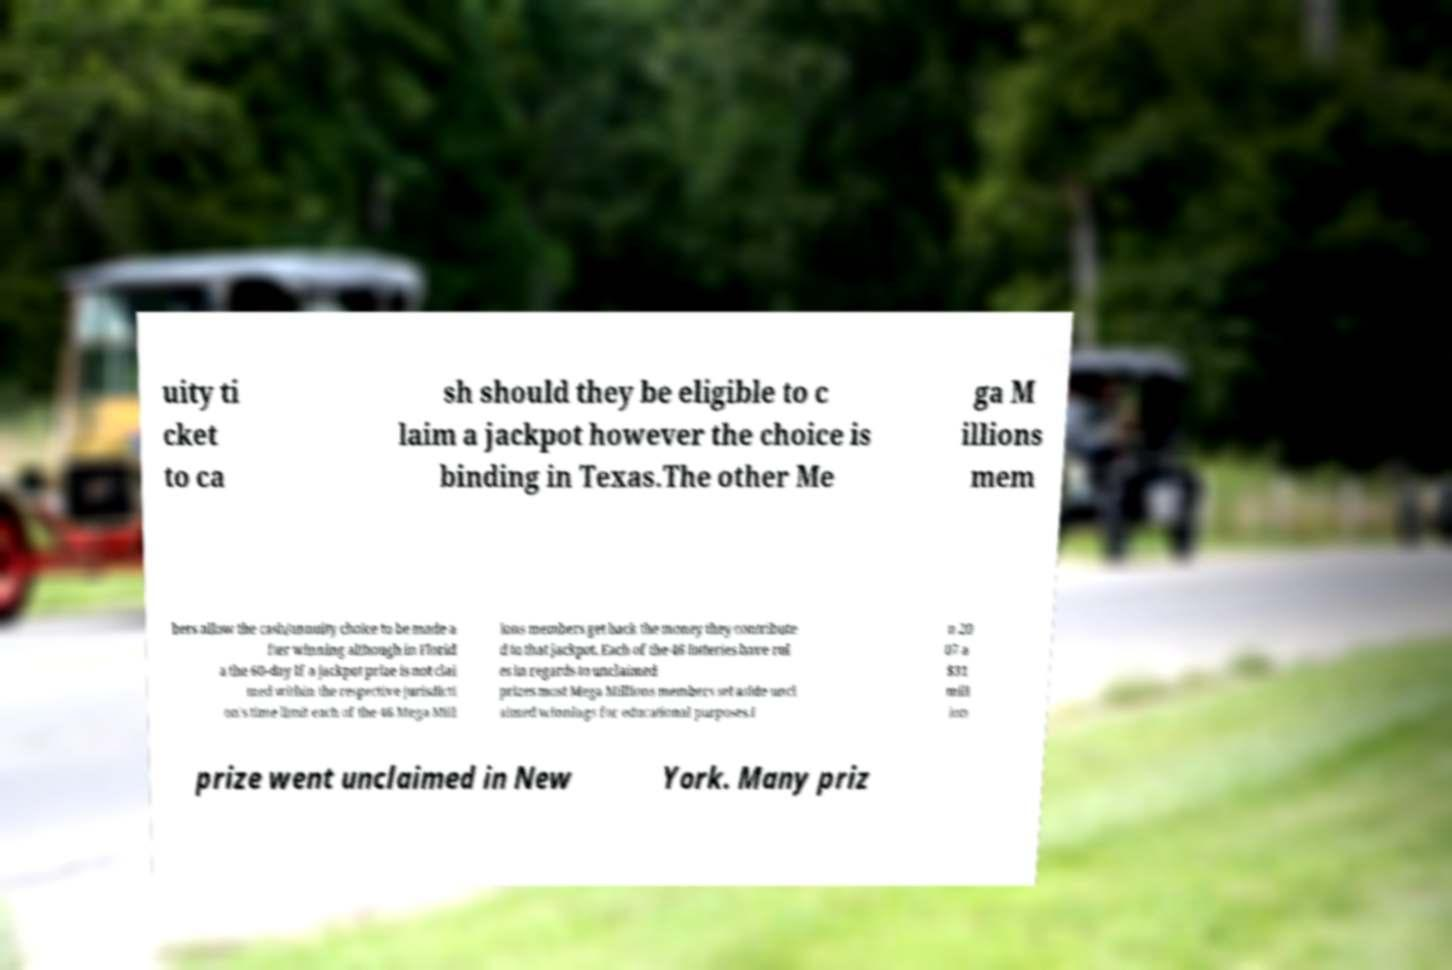Could you extract and type out the text from this image? uity ti cket to ca sh should they be eligible to c laim a jackpot however the choice is binding in Texas.The other Me ga M illions mem bers allow the cash/annuity choice to be made a fter winning although in Florid a the 60-day If a jackpot prize is not clai med within the respective jurisdicti on's time limit each of the 46 Mega Mill ions members get back the money they contribute d to that jackpot. Each of the 46 lotteries have rul es in regards to unclaimed prizes most Mega Millions members set aside uncl aimed winnings for educational purposes.I n 20 07 a $31 mill ion prize went unclaimed in New York. Many priz 